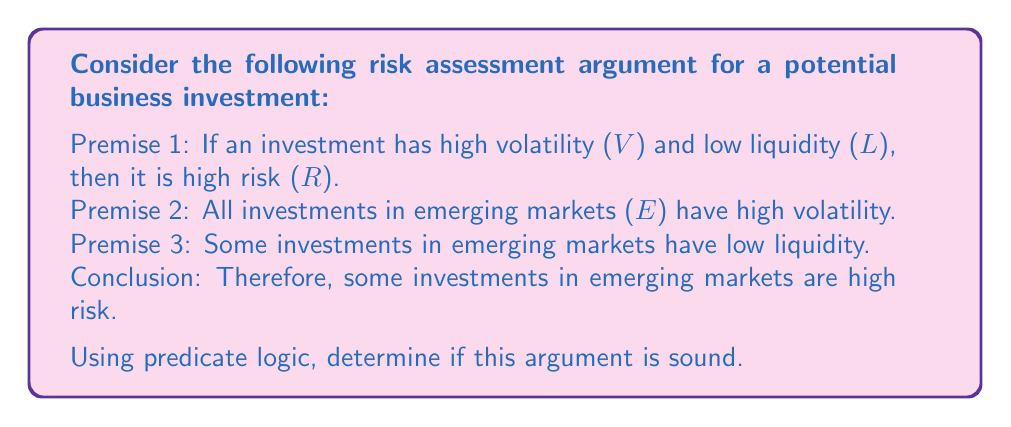What is the answer to this math problem? To determine the soundness of this argument, we need to translate it into predicate logic and evaluate its validity and the truth of its premises.

Let's define our predicates:
$V(x)$: x has high volatility
$L(x)$: x has low liquidity
$R(x)$: x is high risk
$E(x)$: x is an investment in emerging markets

Now, let's translate each statement:

1. Premise 1: $\forall x [(V(x) \land L(x)) \rightarrow R(x)]$
2. Premise 2: $\forall x [E(x) \rightarrow V(x)]$
3. Premise 3: $\exists x [E(x) \land L(x)]$
4. Conclusion: $\exists x [E(x) \land R(x)]$

To prove the validity of this argument, we can use the following steps:

1. From Premise 3, we know that there exists an x such that $E(x) \land L(x)$. Let's call this specific x as 'a'.
2. From Premise 2, we know that $\forall x [E(x) \rightarrow V(x)]$. Since 'a' is in E, we can conclude $V(a)$.
3. Now we have $E(a) \land L(a) \land V(a)$.
4. From Premise 1, we know that $\forall x [(V(x) \land L(x)) \rightarrow R(x)]$. Since 'a' satisfies $V(a) \land L(a)$, we can conclude $R(a)$.
5. Therefore, we have shown that $\exists x [E(x) \land R(x)]$, which is our conclusion.

This proves that the argument is valid. However, for an argument to be sound, it must be valid and all its premises must be true.

In this case:
- Premise 1 is generally accepted in finance theory.
- Premise 2 is a strong generalization and might not always be true for all emerging market investments.
- Premise 3 is likely true, as some emerging market investments do have low liquidity.

Given the potential weakness in Premise 2, a cautious and rational evaluator would consider this argument valid but not necessarily sound due to the uncertainty in the universal claim about emerging market investments having high volatility.
Answer: The argument is valid but not necessarily sound. While the logical structure is correct, the universal claim in Premise 2 about all emerging market investments having high volatility may not always be true, potentially compromising the soundness of the argument. 